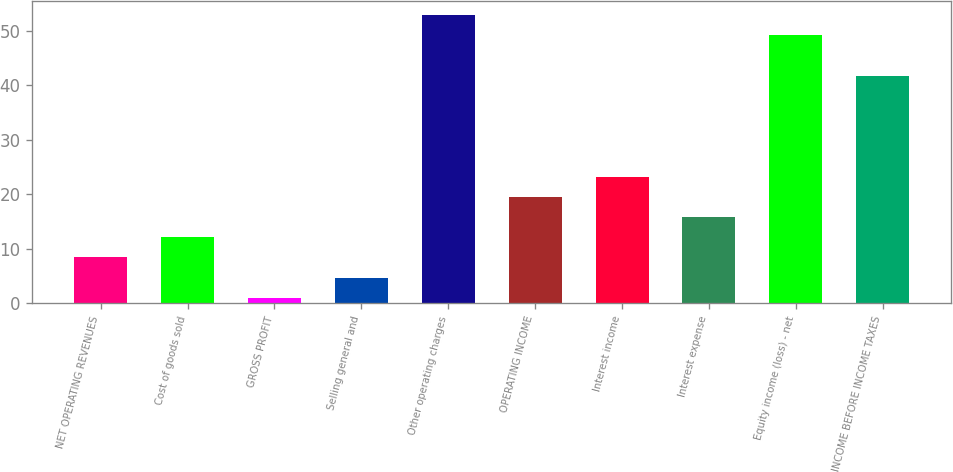Convert chart. <chart><loc_0><loc_0><loc_500><loc_500><bar_chart><fcel>NET OPERATING REVENUES<fcel>Cost of goods sold<fcel>GROSS PROFIT<fcel>Selling general and<fcel>Other operating charges<fcel>OPERATING INCOME<fcel>Interest income<fcel>Interest expense<fcel>Equity income (loss) - net<fcel>INCOME BEFORE INCOME TAXES<nl><fcel>8.4<fcel>12.1<fcel>1<fcel>4.7<fcel>52.8<fcel>19.5<fcel>23.2<fcel>15.8<fcel>49.1<fcel>41.7<nl></chart> 